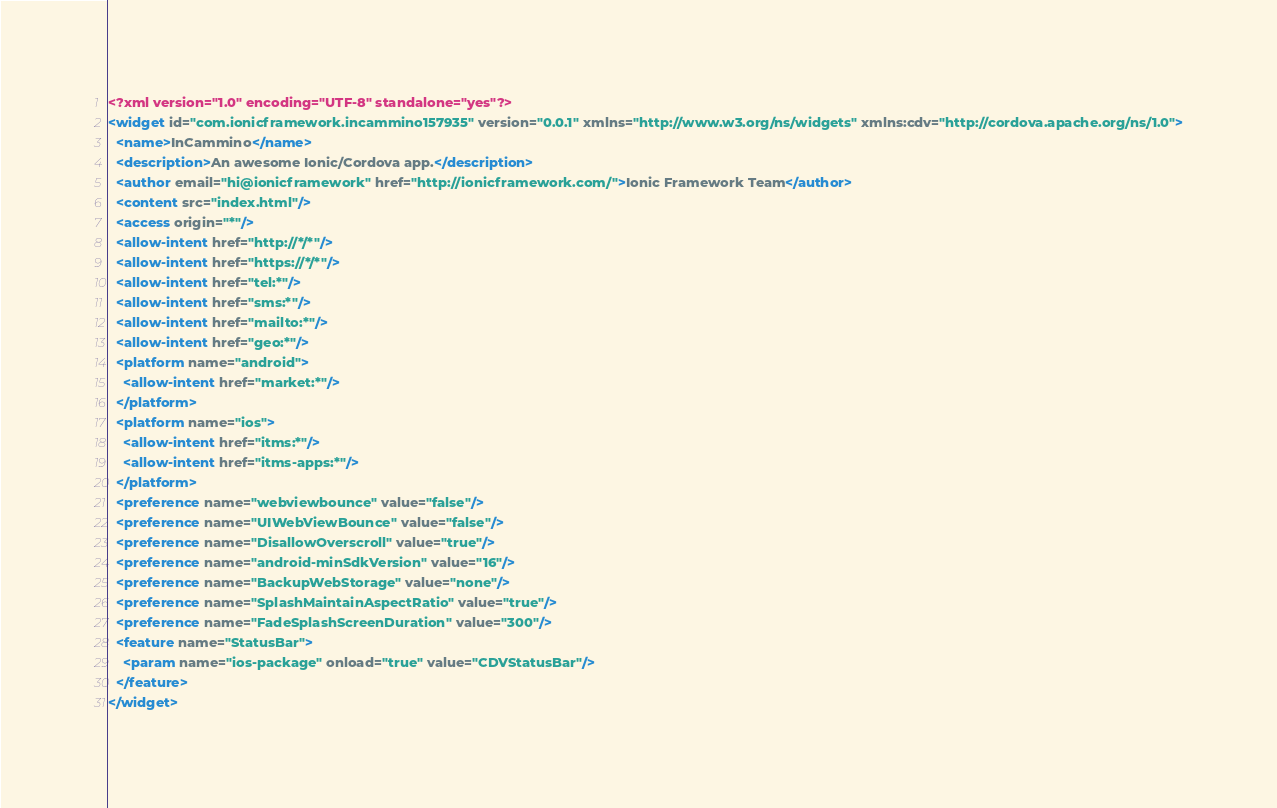<code> <loc_0><loc_0><loc_500><loc_500><_XML_><?xml version="1.0" encoding="UTF-8" standalone="yes"?>
<widget id="com.ionicframework.incammino157935" version="0.0.1" xmlns="http://www.w3.org/ns/widgets" xmlns:cdv="http://cordova.apache.org/ns/1.0">
  <name>InCammino</name>
  <description>An awesome Ionic/Cordova app.</description>
  <author email="hi@ionicframework" href="http://ionicframework.com/">Ionic Framework Team</author>
  <content src="index.html"/>
  <access origin="*"/>
  <allow-intent href="http://*/*"/>
  <allow-intent href="https://*/*"/>
  <allow-intent href="tel:*"/>
  <allow-intent href="sms:*"/>
  <allow-intent href="mailto:*"/>
  <allow-intent href="geo:*"/>
  <platform name="android">
    <allow-intent href="market:*"/>
  </platform>
  <platform name="ios">
    <allow-intent href="itms:*"/>
    <allow-intent href="itms-apps:*"/>
  </platform>
  <preference name="webviewbounce" value="false"/>
  <preference name="UIWebViewBounce" value="false"/>
  <preference name="DisallowOverscroll" value="true"/>
  <preference name="android-minSdkVersion" value="16"/>
  <preference name="BackupWebStorage" value="none"/>
  <preference name="SplashMaintainAspectRatio" value="true"/>
  <preference name="FadeSplashScreenDuration" value="300"/>
  <feature name="StatusBar">
    <param name="ios-package" onload="true" value="CDVStatusBar"/>
  </feature>
</widget></code> 